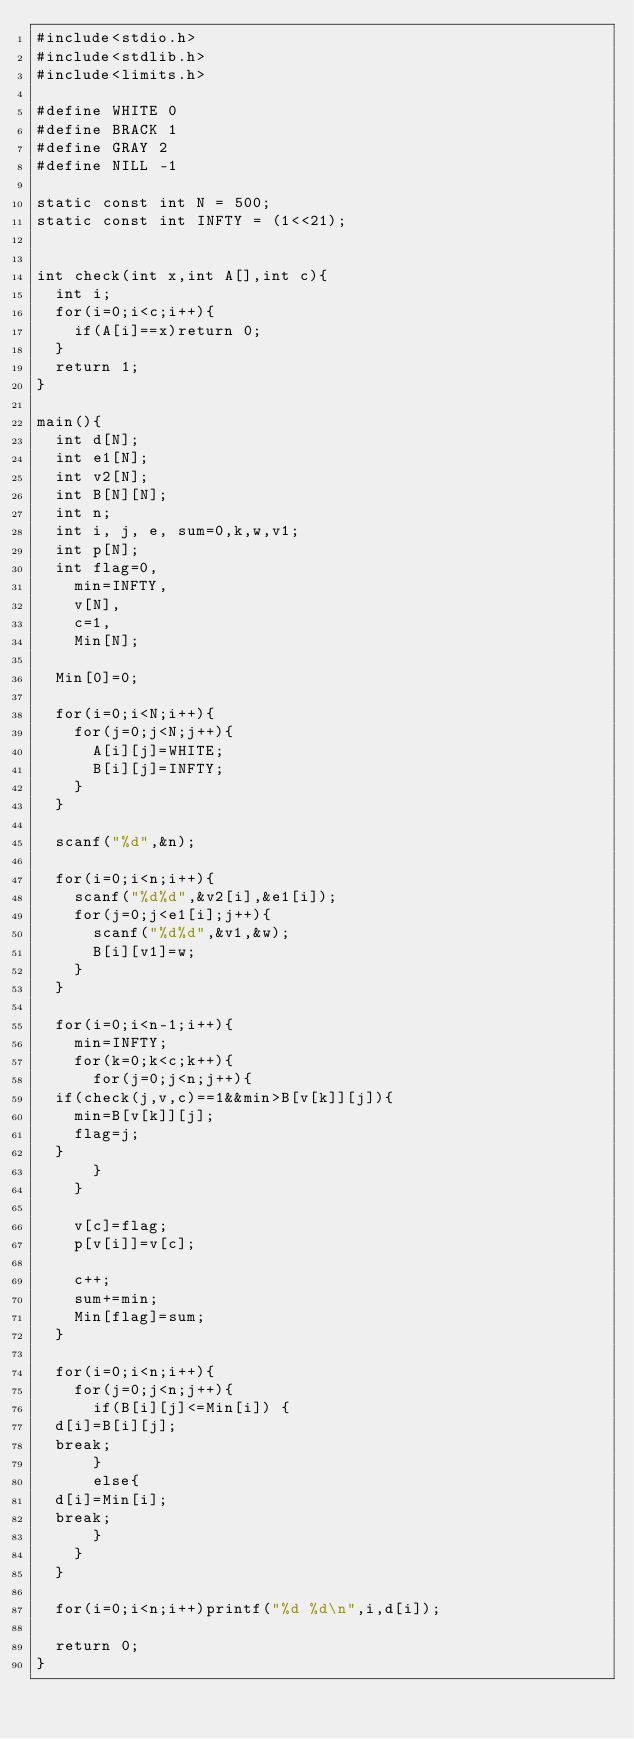Convert code to text. <code><loc_0><loc_0><loc_500><loc_500><_C_>#include<stdio.h>
#include<stdlib.h>
#include<limits.h>

#define WHITE 0
#define BRACK 1
#define GRAY 2
#define NILL -1

static const int N = 500;
static const int INFTY = (1<<21);


int check(int x,int A[],int c){
  int i;
  for(i=0;i<c;i++){
    if(A[i]==x)return 0;
  }
  return 1;
}

main(){
  int d[N];
  int e1[N];
  int v2[N];
  int B[N][N];
  int n;
  int i, j, e, sum=0,k,w,v1;
  int p[N];
  int flag=0,
    min=INFTY,
    v[N],
    c=1,
    Min[N];
  
  Min[0]=0;
  
  for(i=0;i<N;i++){
    for(j=0;j<N;j++){
      A[i][j]=WHITE;
      B[i][j]=INFTY;
    }
  }

  scanf("%d",&n);
  
  for(i=0;i<n;i++){
    scanf("%d%d",&v2[i],&e1[i]);
    for(j=0;j<e1[i];j++){
      scanf("%d%d",&v1,&w);
      B[i][v1]=w;
    }
  }

  for(i=0;i<n-1;i++){
    min=INFTY;
    for(k=0;k<c;k++){
      for(j=0;j<n;j++){
	if(check(j,v,c)==1&&min>B[v[k]][j]){
	  min=B[v[k]][j];
	  flag=j;
	}
      }
    }
    
    v[c]=flag;
    p[v[i]]=v[c];

    c++;
    sum+=min;
    Min[flag]=sum;
  }

  for(i=0;i<n;i++){
    for(j=0;j<n;j++){
      if(B[i][j]<=Min[i]) {
	d[i]=B[i][j];
	break;
      }
      else{
	d[i]=Min[i];
	break;
      }
    }
  }
  
  for(i=0;i<n;i++)printf("%d %d\n",i,d[i]);
  
  return 0;
}</code> 